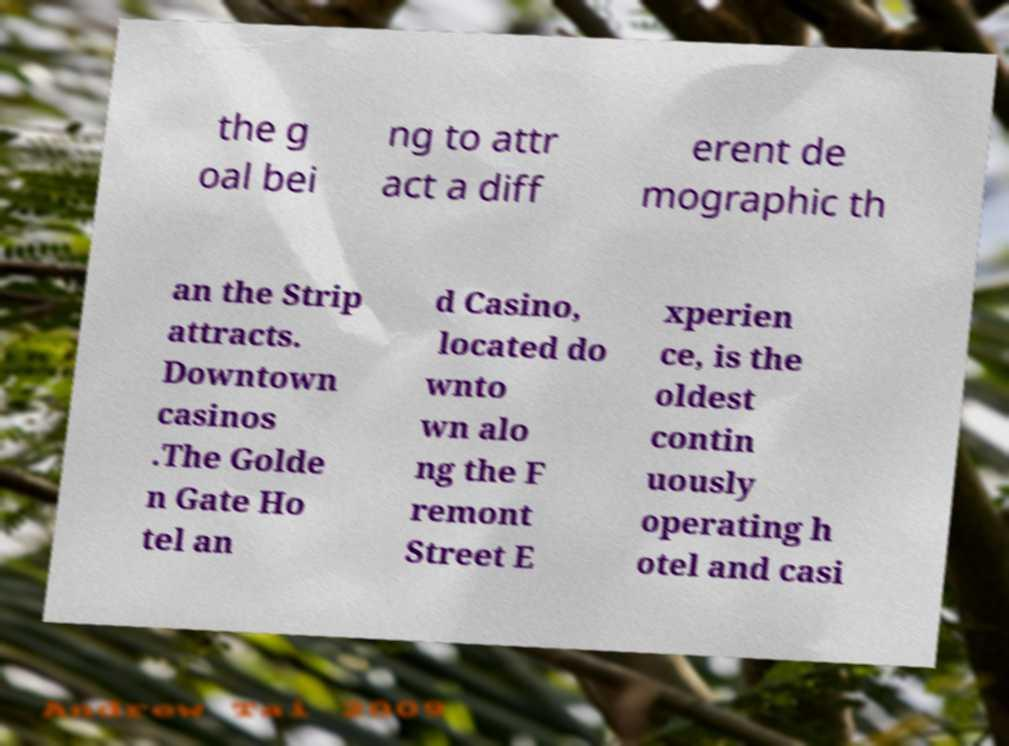There's text embedded in this image that I need extracted. Can you transcribe it verbatim? the g oal bei ng to attr act a diff erent de mographic th an the Strip attracts. Downtown casinos .The Golde n Gate Ho tel an d Casino, located do wnto wn alo ng the F remont Street E xperien ce, is the oldest contin uously operating h otel and casi 